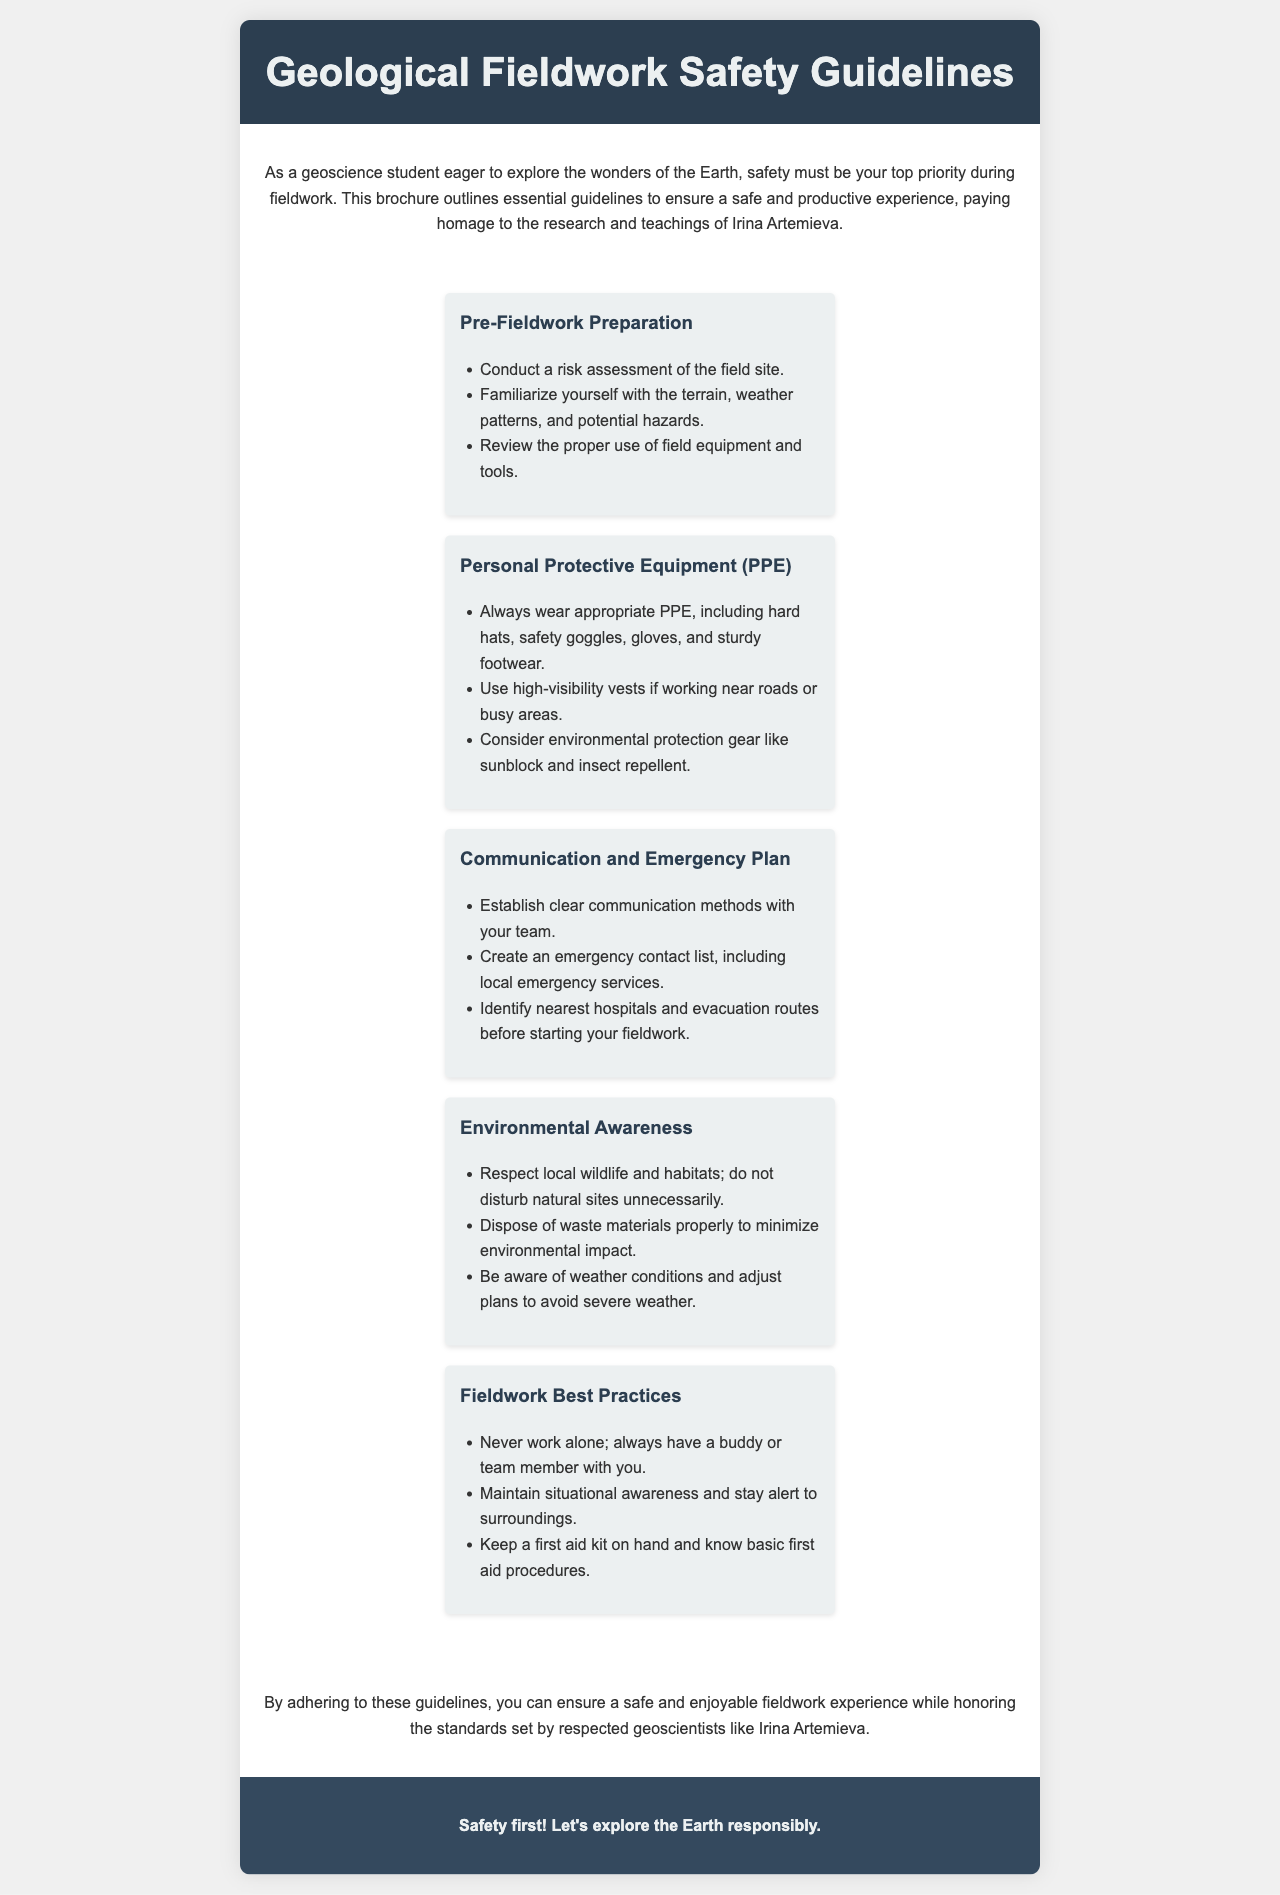What is the title of the document? The title is explicitly stated in the header section of the document.
Answer: Geological Fieldwork Safety Guidelines Who is mentioned as a respected geoscientist in the brochure? The brochure highlights the contributions of a specific individual.
Answer: Irina Artemieva What personal protective equipment is specifically mentioned? The guidelines list essential gear for safety, providing specific examples.
Answer: hard hats, safety goggles, gloves, and sturdy footwear What should you always do during fieldwork regarding teamwork? The guidelines emphasize a certain practice concerning safety while working.
Answer: Never work alone How can you ensure effective communication in the field? The document suggests establishing methods for team coordination and safety.
Answer: Establish clear communication methods What is recommended to respect local wildlife? There is a specific guideline related to interacting with natural environments.
Answer: Do not disturb natural sites unnecessarily What should you keep on hand during fieldwork for emergencies? The guidelines mention the importance of preparedness for accidents.
Answer: first aid kit How should waste materials be handled? The brochure includes instructions on maintaining environmental integrity.
Answer: Dispose of waste materials properly What is the main purpose of the brochure? The document has a clear intention related to safety during fieldwork.
Answer: Ensure a safe and productive experience 